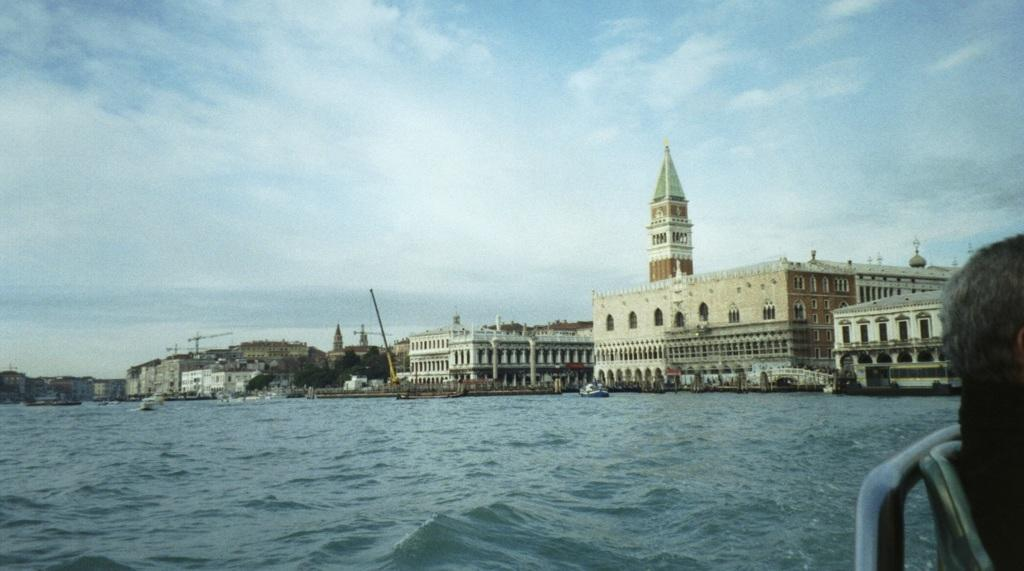What type of structures can be seen in the image? There are many buildings in the image. What is located at the bottom of the image? There is water at the bottom of the image. Can you describe anything on the right side of the image? There appears to be a boat on the right side of the image. What is visible in the sky at the top of the image? There are clouds in the sky at the top of the image. What type of teeth can be seen on the boat in the image? There are no teeth visible on the boat in the image. What kind of jelly is being used to hold the buildings together in the image? There is no jelly present in the image; the buildings are standing on their own. 